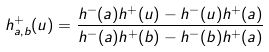<formula> <loc_0><loc_0><loc_500><loc_500>h ^ { + } _ { a , b } ( u ) = \frac { h ^ { - } ( a ) h ^ { + } ( u ) - h ^ { - } ( u ) h ^ { + } ( a ) } { h ^ { - } ( a ) h ^ { + } ( b ) - h ^ { - } ( b ) h ^ { + } ( a ) }</formula> 